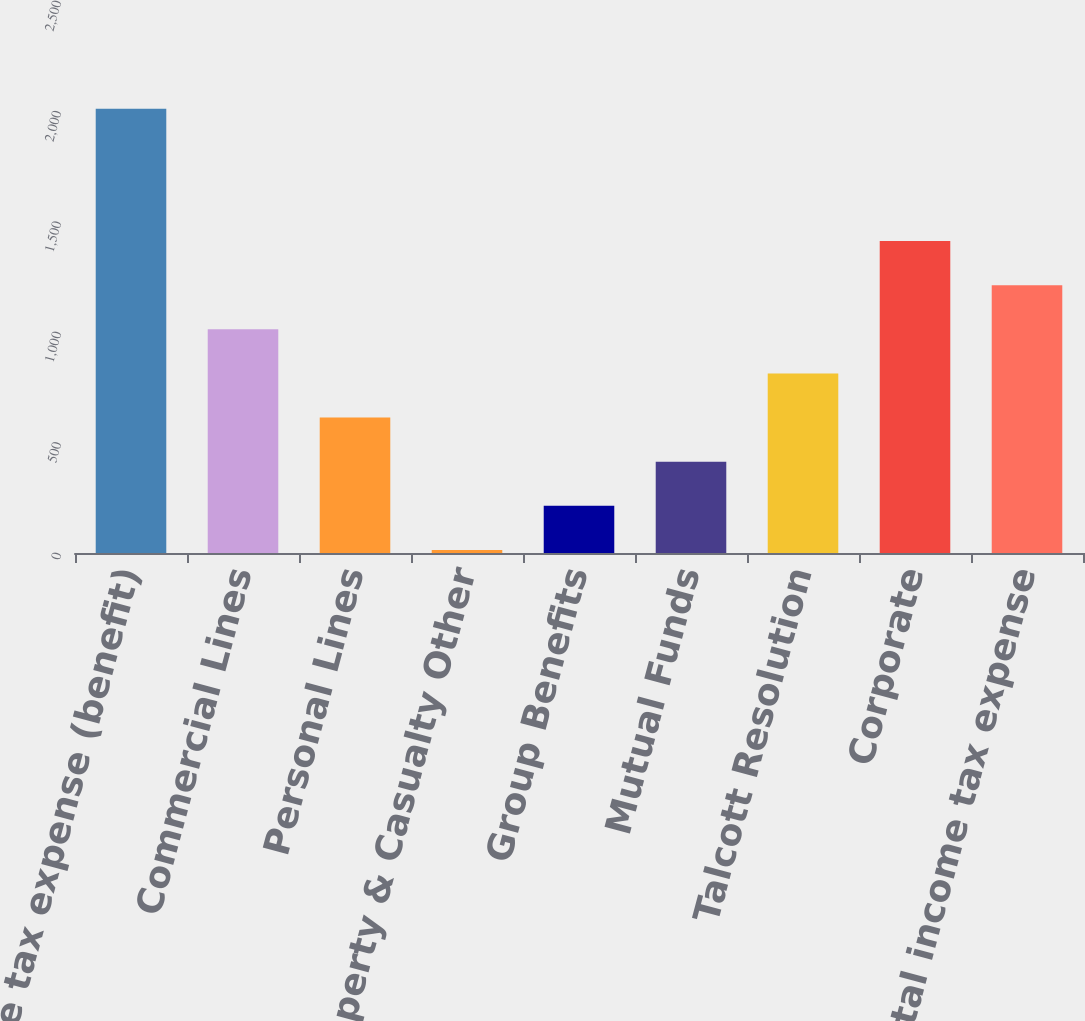Convert chart to OTSL. <chart><loc_0><loc_0><loc_500><loc_500><bar_chart><fcel>Income tax expense (benefit)<fcel>Commercial Lines<fcel>Personal Lines<fcel>Property & Casualty Other<fcel>Group Benefits<fcel>Mutual Funds<fcel>Talcott Resolution<fcel>Corporate<fcel>Total income tax expense<nl><fcel>2012<fcel>1013<fcel>613.4<fcel>14<fcel>213.8<fcel>413.6<fcel>813.2<fcel>1412.6<fcel>1212.8<nl></chart> 